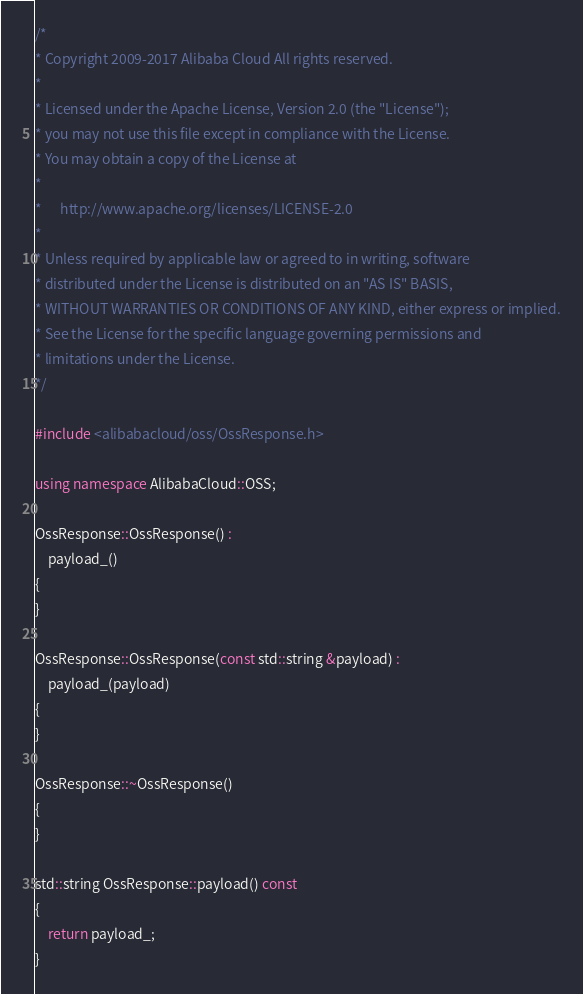Convert code to text. <code><loc_0><loc_0><loc_500><loc_500><_C++_>/*
* Copyright 2009-2017 Alibaba Cloud All rights reserved.
*
* Licensed under the Apache License, Version 2.0 (the "License");
* you may not use this file except in compliance with the License.
* You may obtain a copy of the License at
*
*      http://www.apache.org/licenses/LICENSE-2.0
*
* Unless required by applicable law or agreed to in writing, software
* distributed under the License is distributed on an "AS IS" BASIS,
* WITHOUT WARRANTIES OR CONDITIONS OF ANY KIND, either express or implied.
* See the License for the specific language governing permissions and
* limitations under the License.
*/

#include <alibabacloud/oss/OssResponse.h>

using namespace AlibabaCloud::OSS;

OssResponse::OssResponse() :
    payload_()
{
}

OssResponse::OssResponse(const std::string &payload) :
    payload_(payload)
{
}

OssResponse::~OssResponse()
{
}

std::string OssResponse::payload() const
{
    return payload_;
}
</code> 